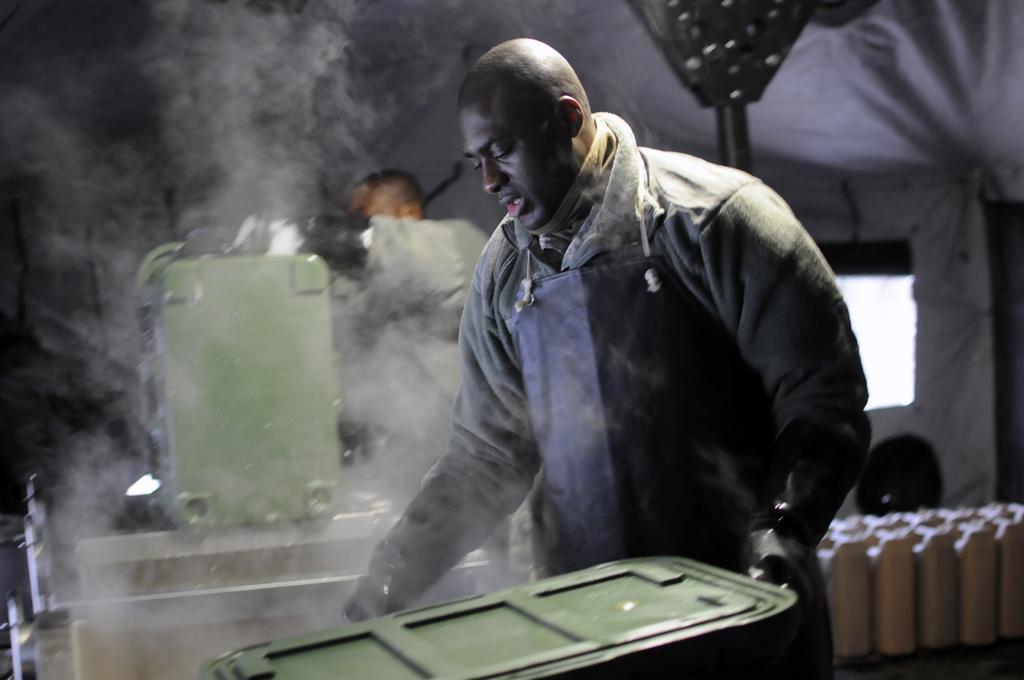How would you summarize this image in a sentence or two? In the image we can see a man standing, wearing clothes and gloves. Here we can see metal containers. There is even another person standing wearing clothes. Here we can see the smoke and the background is slightly blurred. 